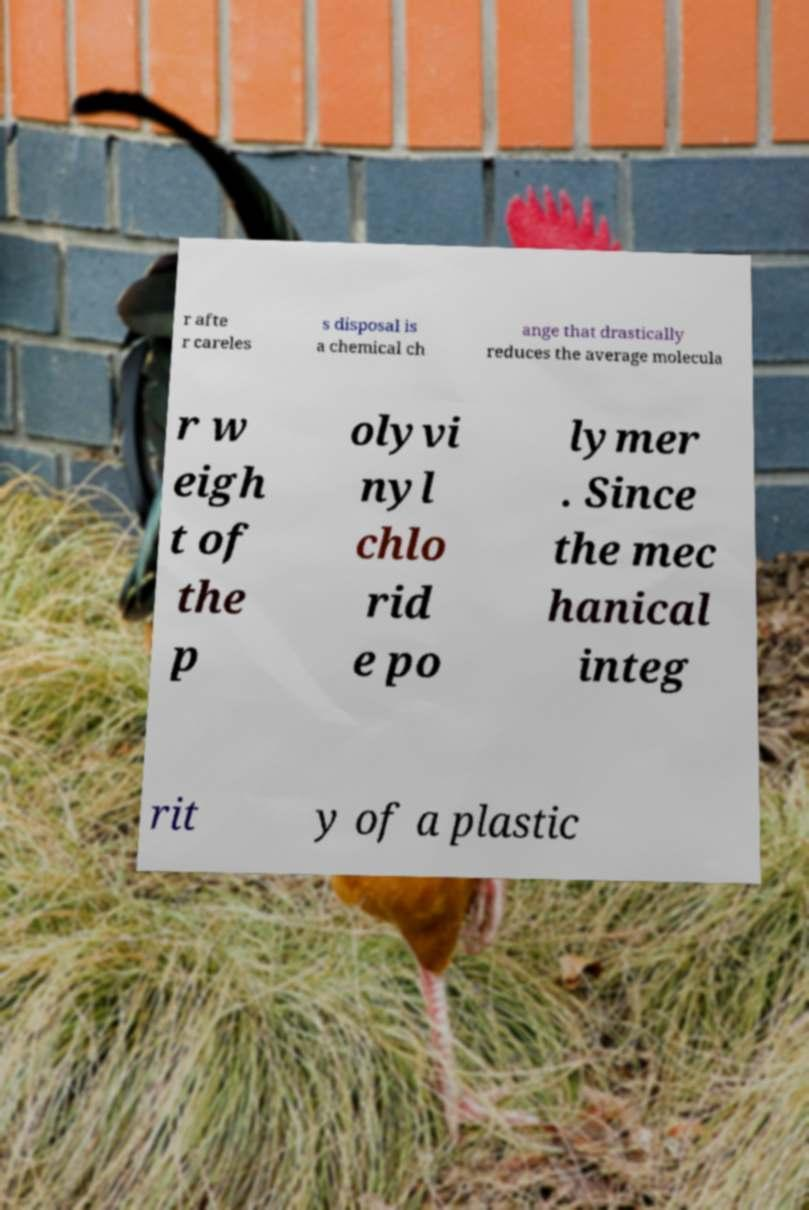What messages or text are displayed in this image? I need them in a readable, typed format. r afte r careles s disposal is a chemical ch ange that drastically reduces the average molecula r w eigh t of the p olyvi nyl chlo rid e po lymer . Since the mec hanical integ rit y of a plastic 